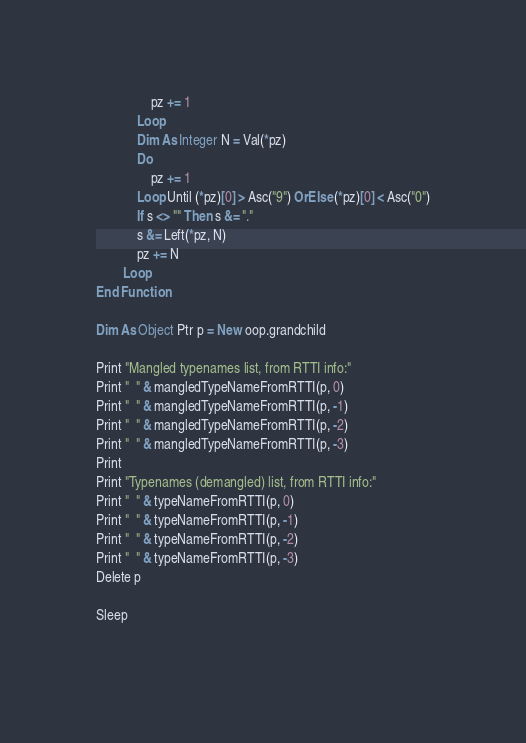<code> <loc_0><loc_0><loc_500><loc_500><_VisualBasic_>				pz += 1
			Loop
			Dim As Integer N = Val(*pz)
			Do
				pz += 1
			Loop Until (*pz)[0] > Asc("9") OrElse (*pz)[0] < Asc("0")
			If s <> "" Then s &= "."
			s &= Left(*pz, N)
			pz += N
		Loop
End Function

Dim As Object Ptr p = New oop.grandchild

Print "Mangled typenames list, from RTTI info:"
Print "  " & mangledTypeNameFromRTTI(p, 0)
Print "  " & mangledTypeNameFromRTTI(p, -1)
Print "  " & mangledTypeNameFromRTTI(p, -2)
Print "  " & mangledTypeNameFromRTTI(p, -3)
Print
Print "Typenames (demangled) list, from RTTI info:"
Print "  " & typeNameFromRTTI(p, 0)
Print "  " & typeNameFromRTTI(p, -1)
Print "  " & typeNameFromRTTI(p, -2)
Print "  " & typeNameFromRTTI(p, -3)
Delete p

Sleep
			
</code> 